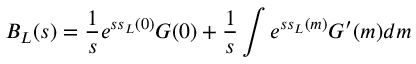<formula> <loc_0><loc_0><loc_500><loc_500>B _ { L } ( s ) = \frac { 1 } { s } e ^ { s s _ { L } ( 0 ) } G ( 0 ) + \frac { 1 } { s } \int e ^ { s s _ { L } ( m ) } G ^ { \prime } ( m ) d m</formula> 